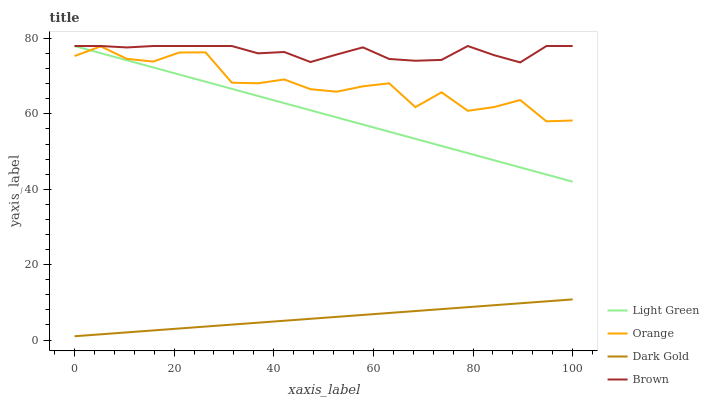Does Dark Gold have the minimum area under the curve?
Answer yes or no. Yes. Does Brown have the maximum area under the curve?
Answer yes or no. Yes. Does Light Green have the minimum area under the curve?
Answer yes or no. No. Does Light Green have the maximum area under the curve?
Answer yes or no. No. Is Dark Gold the smoothest?
Answer yes or no. Yes. Is Orange the roughest?
Answer yes or no. Yes. Is Brown the smoothest?
Answer yes or no. No. Is Brown the roughest?
Answer yes or no. No. Does Dark Gold have the lowest value?
Answer yes or no. Yes. Does Light Green have the lowest value?
Answer yes or no. No. Does Light Green have the highest value?
Answer yes or no. Yes. Does Dark Gold have the highest value?
Answer yes or no. No. Is Dark Gold less than Orange?
Answer yes or no. Yes. Is Brown greater than Orange?
Answer yes or no. Yes. Does Orange intersect Light Green?
Answer yes or no. Yes. Is Orange less than Light Green?
Answer yes or no. No. Is Orange greater than Light Green?
Answer yes or no. No. Does Dark Gold intersect Orange?
Answer yes or no. No. 